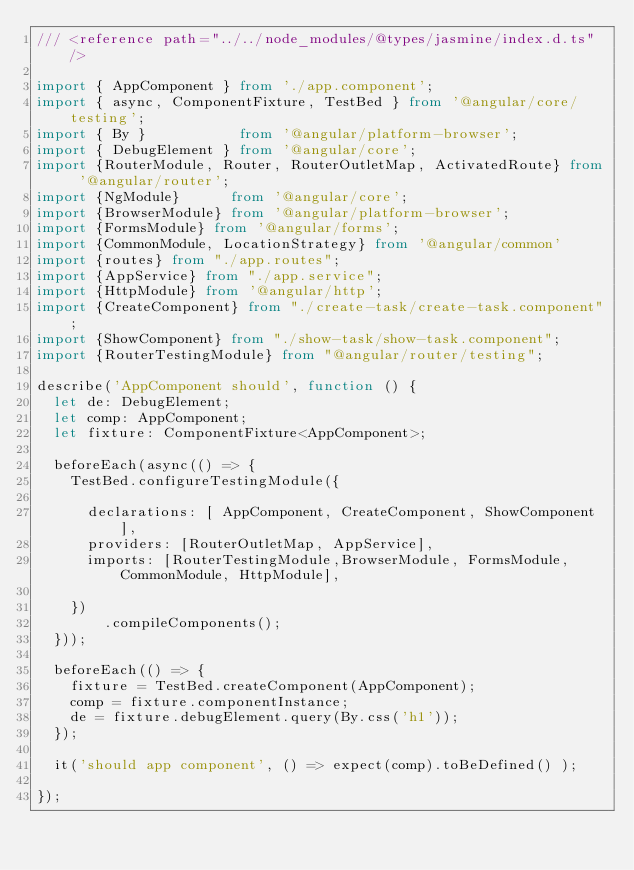Convert code to text. <code><loc_0><loc_0><loc_500><loc_500><_TypeScript_>/// <reference path="../../node_modules/@types/jasmine/index.d.ts" />

import { AppComponent } from './app.component';
import { async, ComponentFixture, TestBed } from '@angular/core/testing';
import { By }           from '@angular/platform-browser';
import { DebugElement } from '@angular/core';
import {RouterModule, Router, RouterOutletMap, ActivatedRoute} from '@angular/router';
import {NgModule}      from '@angular/core';
import {BrowserModule} from '@angular/platform-browser';
import {FormsModule} from '@angular/forms';
import {CommonModule, LocationStrategy} from '@angular/common'
import {routes} from "./app.routes";
import {AppService} from "./app.service";
import {HttpModule} from '@angular/http';
import {CreateComponent} from "./create-task/create-task.component";
import {ShowComponent} from "./show-task/show-task.component";
import {RouterTestingModule} from "@angular/router/testing";

describe('AppComponent should', function () {
  let de: DebugElement;
  let comp: AppComponent;
  let fixture: ComponentFixture<AppComponent>;

  beforeEach(async(() => {
    TestBed.configureTestingModule({

      declarations: [ AppComponent, CreateComponent, ShowComponent ],
      providers: [RouterOutletMap, AppService],
      imports: [RouterTestingModule,BrowserModule, FormsModule, CommonModule, HttpModule],

    })
        .compileComponents();
  }));

  beforeEach(() => {
    fixture = TestBed.createComponent(AppComponent);
    comp = fixture.componentInstance;
    de = fixture.debugElement.query(By.css('h1'));
  });

  it('should app component', () => expect(comp).toBeDefined() );

});</code> 